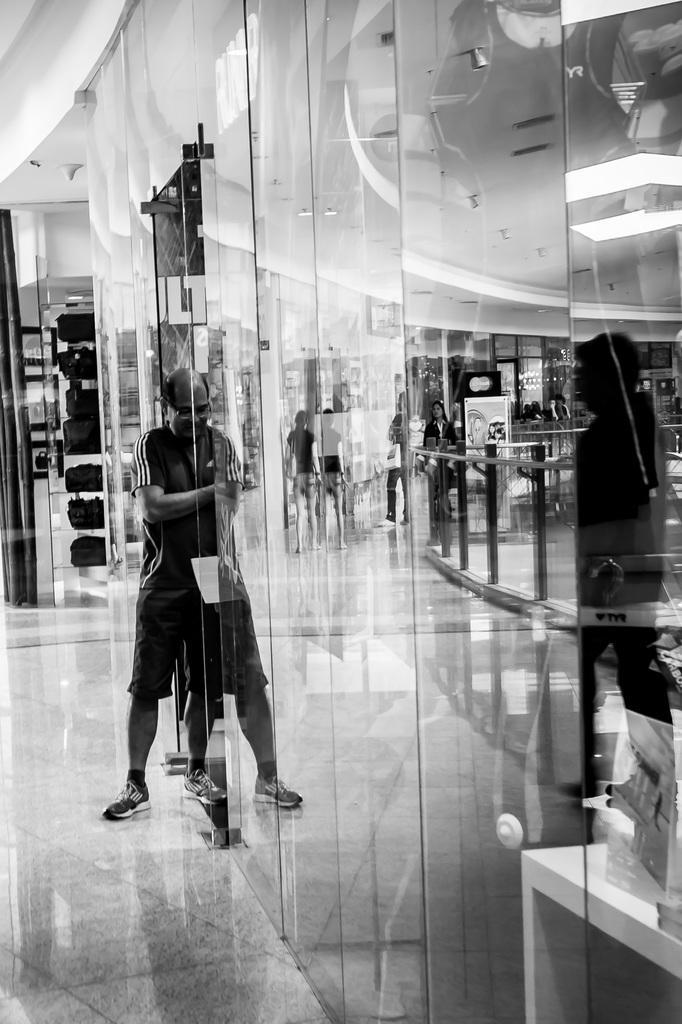Could you give a brief overview of what you see in this image? In this image we can see a person is standing on the floor. Here we can see glasses, ceiling, lights, railing, bags, and other objects. Through the glasses we can see few people. 